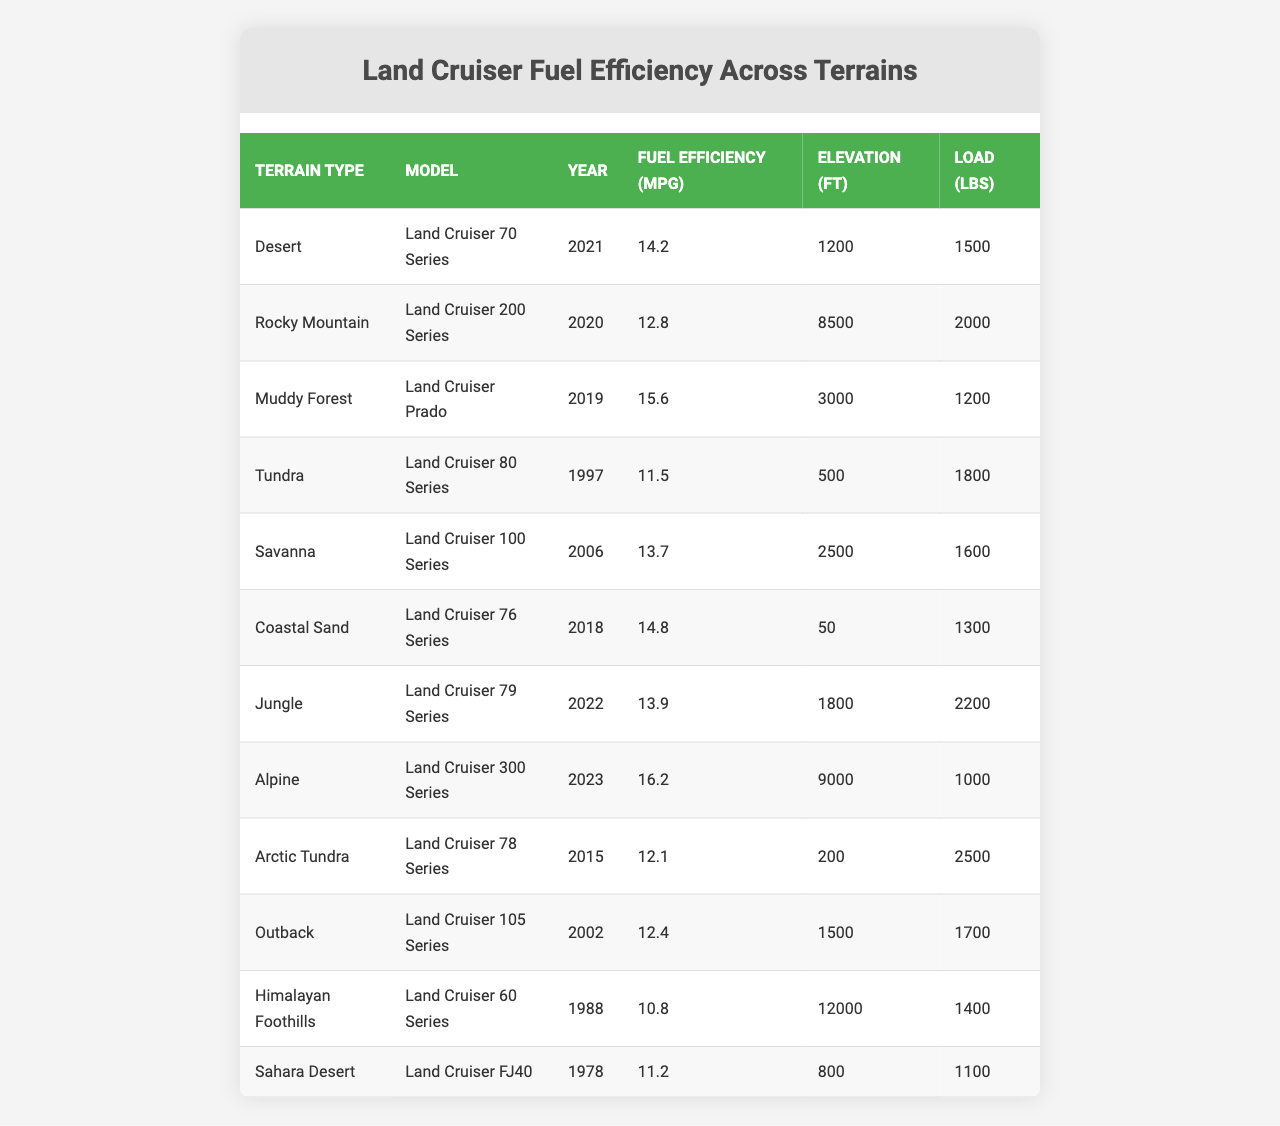What is the fuel efficiency of the Land Cruiser 300 Series? The fuel efficiency of the Land Cruiser 300 Series listed in the table is 16.2 mpg.
Answer: 16.2 mpg Which Land Cruiser model has the highest fuel efficiency? The Land Cruiser 300 Series has the highest fuel efficiency at 16.2 mpg, as shown in the table.
Answer: Land Cruiser 300 Series What is the fuel efficiency of the Land Cruiser 70 Series when driving in the desert? In the desert, the Land Cruiser 70 Series has a fuel efficiency of 14.2 mpg.
Answer: 14.2 mpg Is the fuel efficiency of the Land Cruiser 200 Series greater than 12 mpg? The fuel efficiency of the Land Cruiser 200 Series is 12.8 mpg, which is greater than 12 mpg.
Answer: Yes What is the average fuel efficiency of the Land Cruisers in the table? To find the average, add the fuel efficiencies: 14.2 + 12.8 + 15.6 + 11.5 + 13.7 + 14.8 + 13.9 + 16.2 + 12.1 + 12.4 + 10.8 + 11.2 =  149.2. There are 12 models, so dividing gives 149.2 / 12 = approximately 12.43 mpg.
Answer: 12.43 mpg How much load does the Land Cruiser Prado carry, and how does it compare with the Land Cruiser 80 Series? The Land Cruiser Prado carries 1200 lbs, while the Land Cruiser 80 Series carries 1800 lbs. Therefore, the Land Cruiser 80 Series carries 600 lbs more than the Prado.
Answer: Land Cruiser 80 Series carries 600 lbs more Which terrain type is associated with the greatest elevation and what is that elevation? The Himalayan Foothills have the greatest elevation of 12000 ft, as shown in the table.
Answer: 12000 ft Is the fuel efficiency for driving in the Arctic Tundra better, worse, or equal to that of the Tundra? The Arctic Tundra's fuel efficiency is 12.1 mpg, while the Tundra's efficiency is 11.5 mpg. Therefore, the Arctic Tundra is better.
Answer: Better Which Land Cruiser model from 2015 has a fuel efficiency below 13 mpg? The Land Cruiser 78 Series from 2015 has a fuel efficiency of 12.1 mpg, which is below 13 mpg.
Answer: Land Cruiser 78 Series What is the difference in fuel efficiency between the Land Cruiser 100 Series and the Land Cruiser Prado? The Land Cruiser 100 Series has a fuel efficiency of 13.7 mpg, and the Prado's efficiency is 15.6 mpg. The difference is 15.6 - 13.7 = 1.9 mpg, meaning the Prado is more efficient by that amount.
Answer: 1.9 mpg 